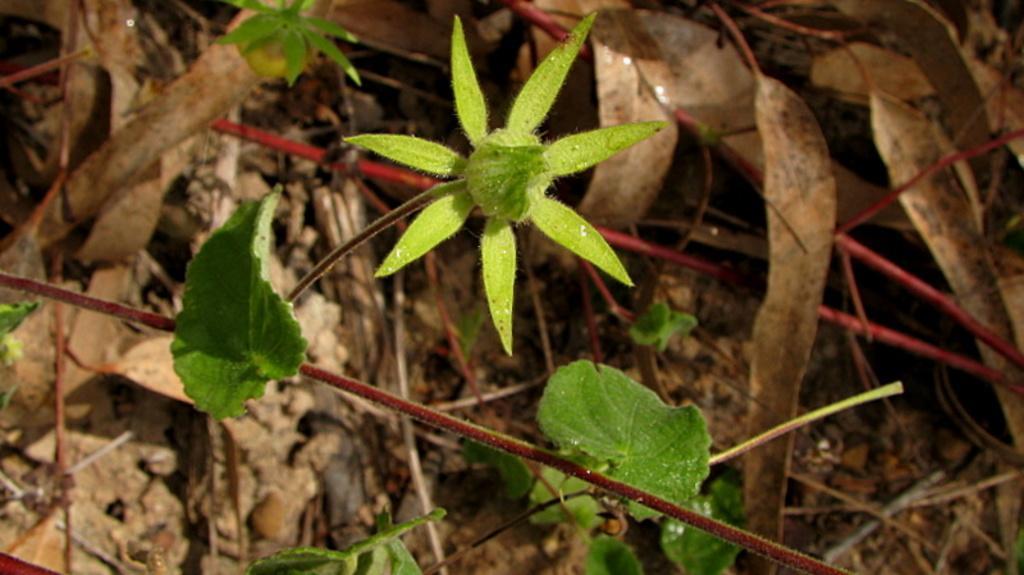Please provide a concise description of this image. In this picture there are few green leaves and there are few dried leaves in the right corner. 